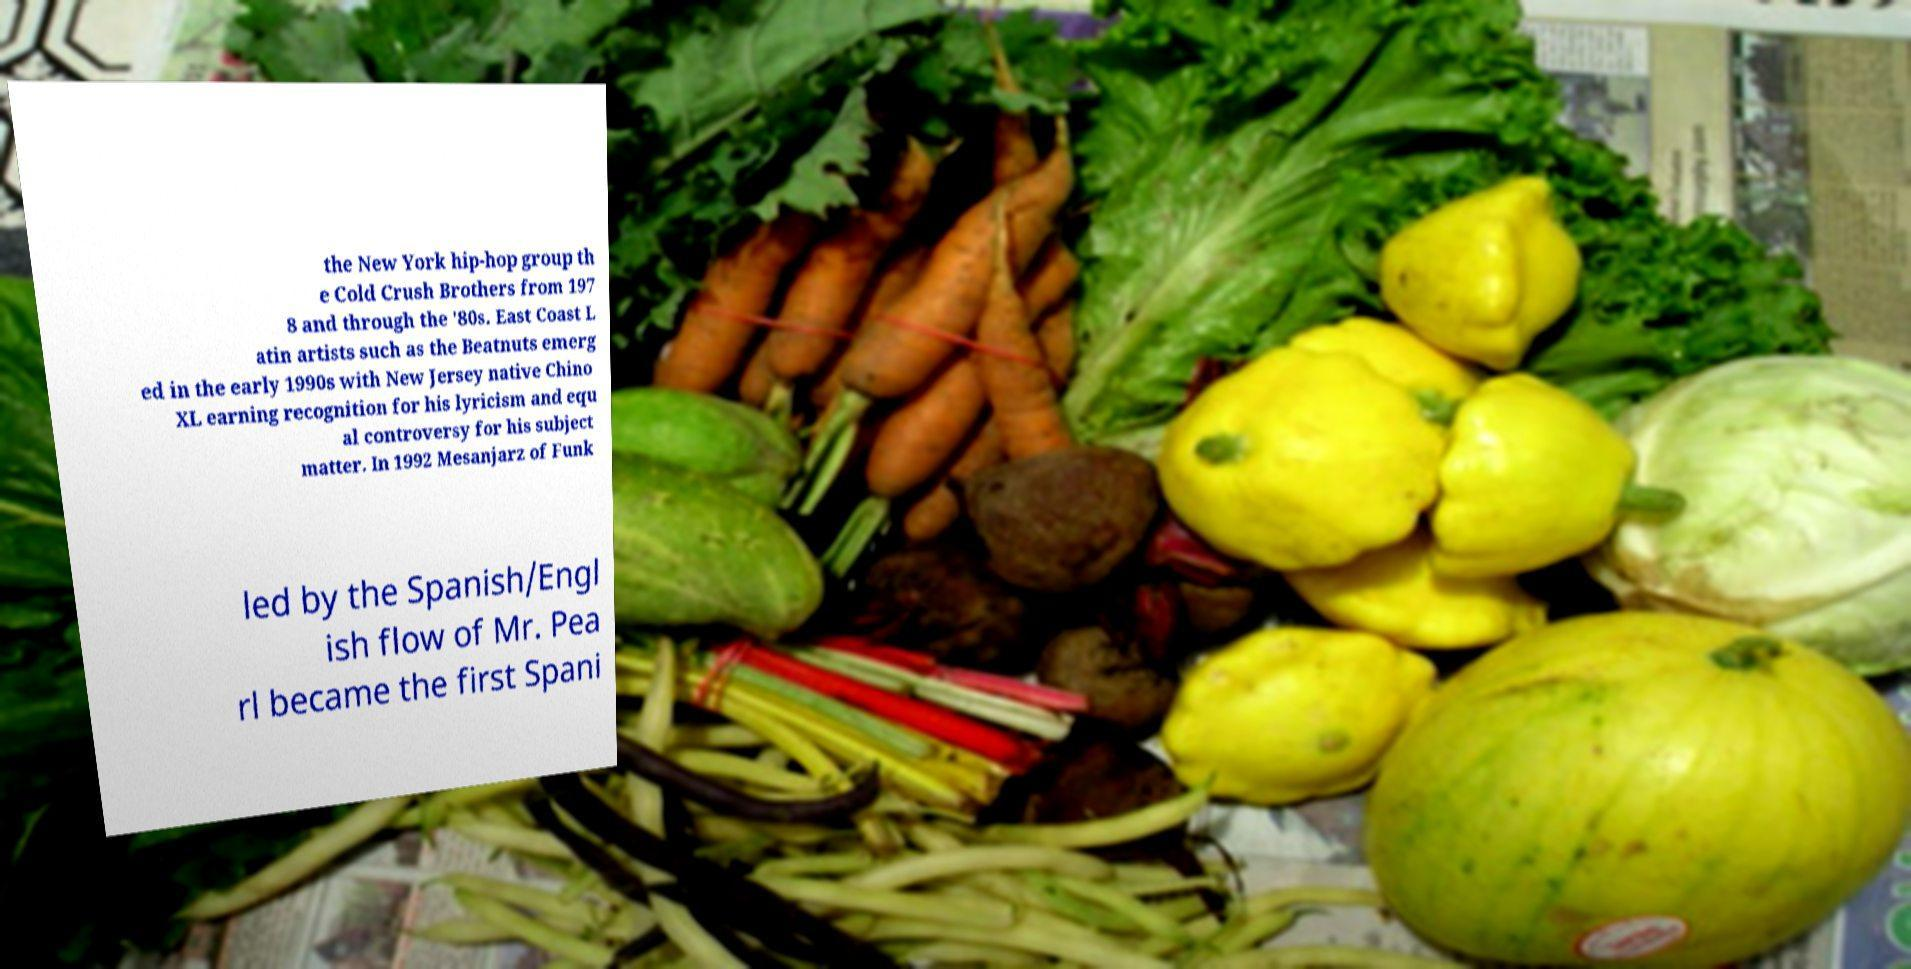Can you accurately transcribe the text from the provided image for me? the New York hip-hop group th e Cold Crush Brothers from 197 8 and through the '80s. East Coast L atin artists such as the Beatnuts emerg ed in the early 1990s with New Jersey native Chino XL earning recognition for his lyricism and equ al controversy for his subject matter. In 1992 Mesanjarz of Funk led by the Spanish/Engl ish flow of Mr. Pea rl became the first Spani 